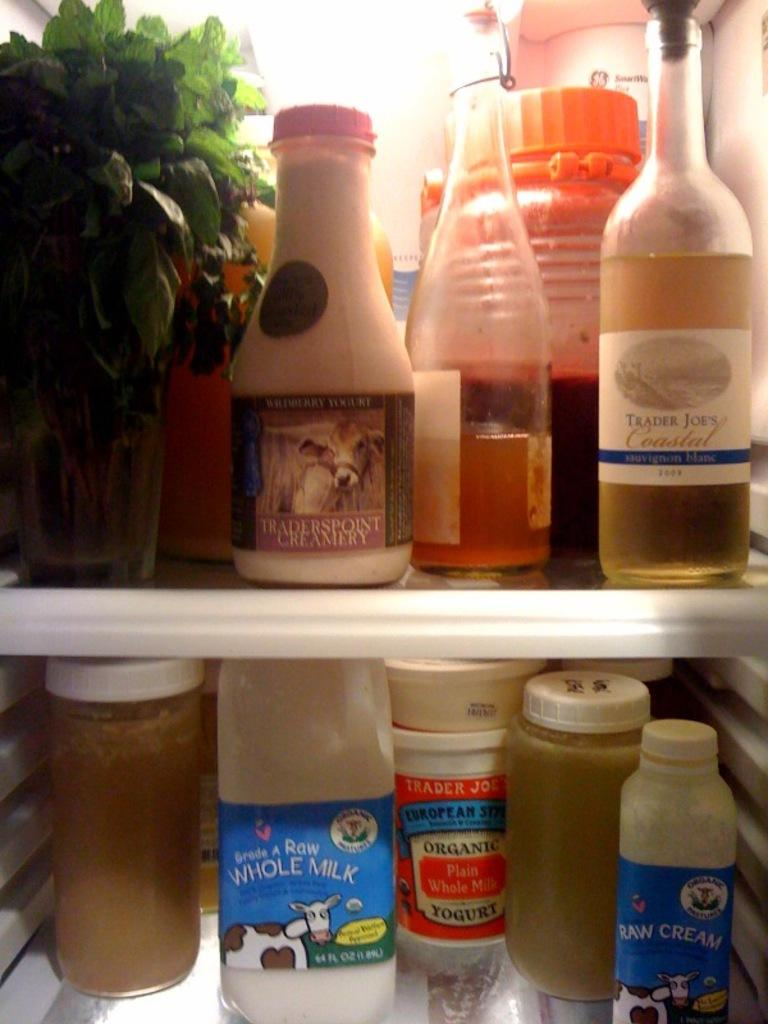<image>
Provide a brief description of the given image. Whole milk in the refrigerator with a cow on the label. 